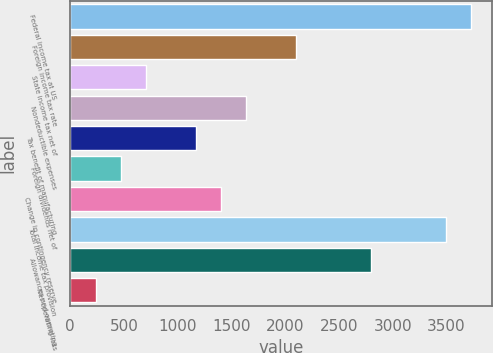Convert chart. <chart><loc_0><loc_0><loc_500><loc_500><bar_chart><fcel>Federal income tax at US<fcel>Foreign income tax rate<fcel>State income tax net of<fcel>Nondeductible expenses<fcel>Tax benefit of manufacturing<fcel>Foreign dividends net of<fcel>Change in contingency reserve<fcel>Total income tax provision<fcel>Allowances and operating<fcel>Net operating loss<nl><fcel>3732.2<fcel>2103.3<fcel>707.1<fcel>1637.9<fcel>1172.5<fcel>474.4<fcel>1405.2<fcel>3499.5<fcel>2801.4<fcel>241.7<nl></chart> 